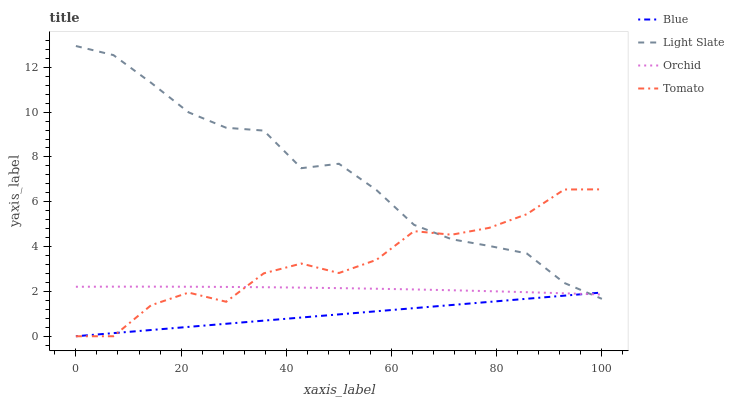Does Blue have the minimum area under the curve?
Answer yes or no. Yes. Does Light Slate have the maximum area under the curve?
Answer yes or no. Yes. Does Tomato have the minimum area under the curve?
Answer yes or no. No. Does Tomato have the maximum area under the curve?
Answer yes or no. No. Is Blue the smoothest?
Answer yes or no. Yes. Is Tomato the roughest?
Answer yes or no. Yes. Is Light Slate the smoothest?
Answer yes or no. No. Is Light Slate the roughest?
Answer yes or no. No. Does Blue have the lowest value?
Answer yes or no. Yes. Does Light Slate have the lowest value?
Answer yes or no. No. Does Light Slate have the highest value?
Answer yes or no. Yes. Does Tomato have the highest value?
Answer yes or no. No. Does Tomato intersect Light Slate?
Answer yes or no. Yes. Is Tomato less than Light Slate?
Answer yes or no. No. Is Tomato greater than Light Slate?
Answer yes or no. No. 